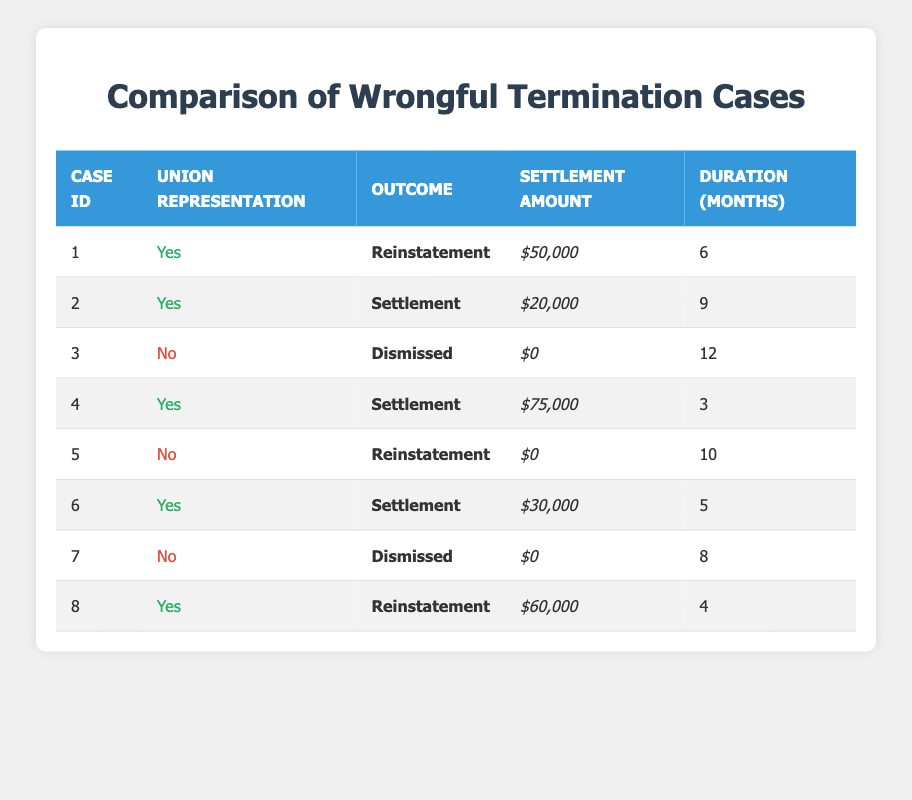What is the outcome for Case ID 1? According to the table, the outcome listed for Case ID 1 is "Reinstatement."
Answer: Reinstatement How many cases resulted in a Settlement and had union representation? A review of the table shows that there are 4 cases with union representation that resulted in a Settlement (Case IDs 2, 4, 6, and 8).
Answer: 4 What is the average settlement amount for cases with union representation? To find the average, add the settlement amounts for Cases 1, 2, 4, 6, and 8: (50000 + 20000 + 75000 + 30000 + 60000) = 235000. There are 5 cases, so the average is 235000 / 5 = 47000.
Answer: 47000 Did any non-union cases have a settlement amount greater than zero? Looking at the non-union cases (Case IDs 3, 5, and 7), all of them have a settlement amount of $0. Thus, the answer is no.
Answer: No Which case had the longest duration, and what was its outcome? Reviewing the duration column reveals that Case ID 3 has the longest duration of 12 months, and its outcome is "Dismissed."
Answer: Case ID 3; Dismissed How many union cases resulted in Reinstatement? From the table, there are 2 cases with union representation that resulted in Reinstatement (Case IDs 1 and 8).
Answer: 2 What is the total settlement amount for all cases? The total can be calculated by summing all settlement amounts: 50000 + 20000 + 0 + 75000 + 0 + 30000 + 0 + 60000 = 235000.
Answer: 235000 Is it true that all non-union cases were dismissed? Examining the non-union cases, we see that Case ID 5 had a "Reinstatement" outcome, so it is false that all non-union cases were dismissed.
Answer: No What is the shortest duration for a case with union representation? The shortest duration among the union cases is in Case ID 4, which lasted 3 months.
Answer: 3 months 